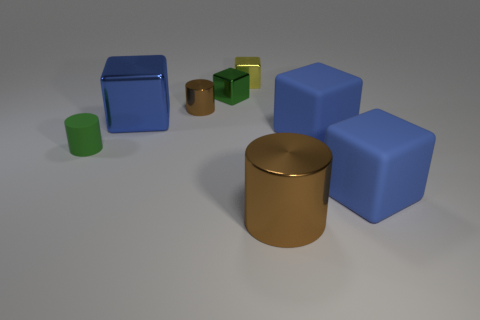Subtract all cyan cylinders. How many blue cubes are left? 3 Subtract 2 blocks. How many blocks are left? 3 Subtract all yellow cubes. How many cubes are left? 4 Subtract all green blocks. How many blocks are left? 4 Subtract all cyan blocks. Subtract all green cylinders. How many blocks are left? 5 Add 1 green rubber cylinders. How many objects exist? 9 Subtract all blocks. How many objects are left? 3 Add 3 small green metal blocks. How many small green metal blocks exist? 4 Subtract 2 blue blocks. How many objects are left? 6 Subtract all green things. Subtract all tiny cylinders. How many objects are left? 4 